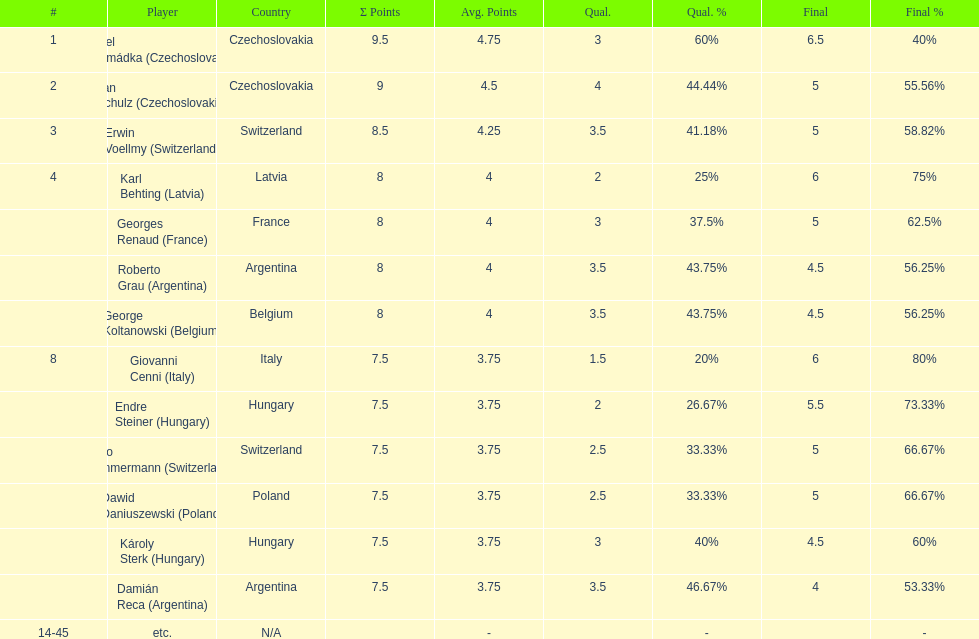Parse the full table. {'header': ['#', 'Player', 'Country', 'Σ Points', 'Avg. Points', 'Qual.', 'Qual. %', 'Final', 'Final %'], 'rows': [['1', 'Karel Hromádka\xa0(Czechoslovakia)', 'Czechoslovakia', '9.5', '4.75', '3', '60%', '6.5', '40%'], ['2', 'Jan Schulz\xa0(Czechoslovakia)', 'Czechoslovakia', '9', '4.5', '4', '44.44%', '5', '55.56%'], ['3', 'Erwin Voellmy\xa0(Switzerland)', 'Switzerland', '8.5', '4.25', '3.5', '41.18%', '5', '58.82%'], ['4', 'Karl Behting\xa0(Latvia)', 'Latvia', '8', '4', '2', '25%', '6', '75%'], ['', 'Georges Renaud\xa0(France)', 'France', '8', '4', '3', '37.5%', '5', '62.5%'], ['', 'Roberto Grau\xa0(Argentina)', 'Argentina', '8', '4', '3.5', '43.75%', '4.5', '56.25%'], ['', 'George Koltanowski\xa0(Belgium)', 'Belgium', '8', '4', '3.5', '43.75%', '4.5', '56.25%'], ['8', 'Giovanni Cenni\xa0(Italy)', 'Italy', '7.5', '3.75', '1.5', '20%', '6', '80%'], ['', 'Endre Steiner\xa0(Hungary)', 'Hungary', '7.5', '3.75', '2', '26.67%', '5.5', '73.33%'], ['', 'Otto Zimmermann\xa0(Switzerland)', 'Switzerland', '7.5', '3.75', '2.5', '33.33%', '5', '66.67%'], ['', 'Dawid Daniuszewski\xa0(Poland)', 'Poland', '7.5', '3.75', '2.5', '33.33%', '5', '66.67%'], ['', 'Károly Sterk\xa0(Hungary)', 'Hungary', '7.5', '3.75', '3', '40%', '4.5', '60%'], ['', 'Damián Reca\xa0(Argentina)', 'Argentina', '7.5', '3.75', '3.5', '46.67%', '4', '53.33%'], ['14-45', 'etc.', 'N/A', '', '-', '', '-', '', '-']]} Jan schulz is ranked immediately below which player? Karel Hromádka. 